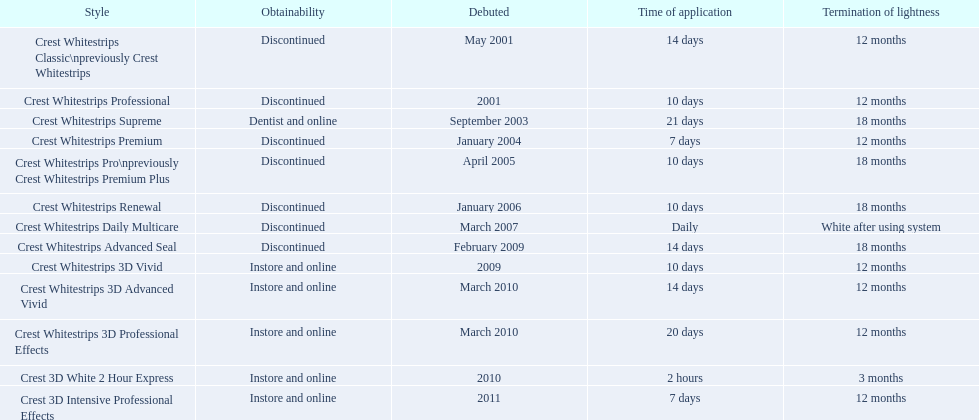When was crest whitestrips 3d advanced vivid introduced? March 2010. What other product was introduced in march 2010? Crest Whitestrips 3D Professional Effects. 